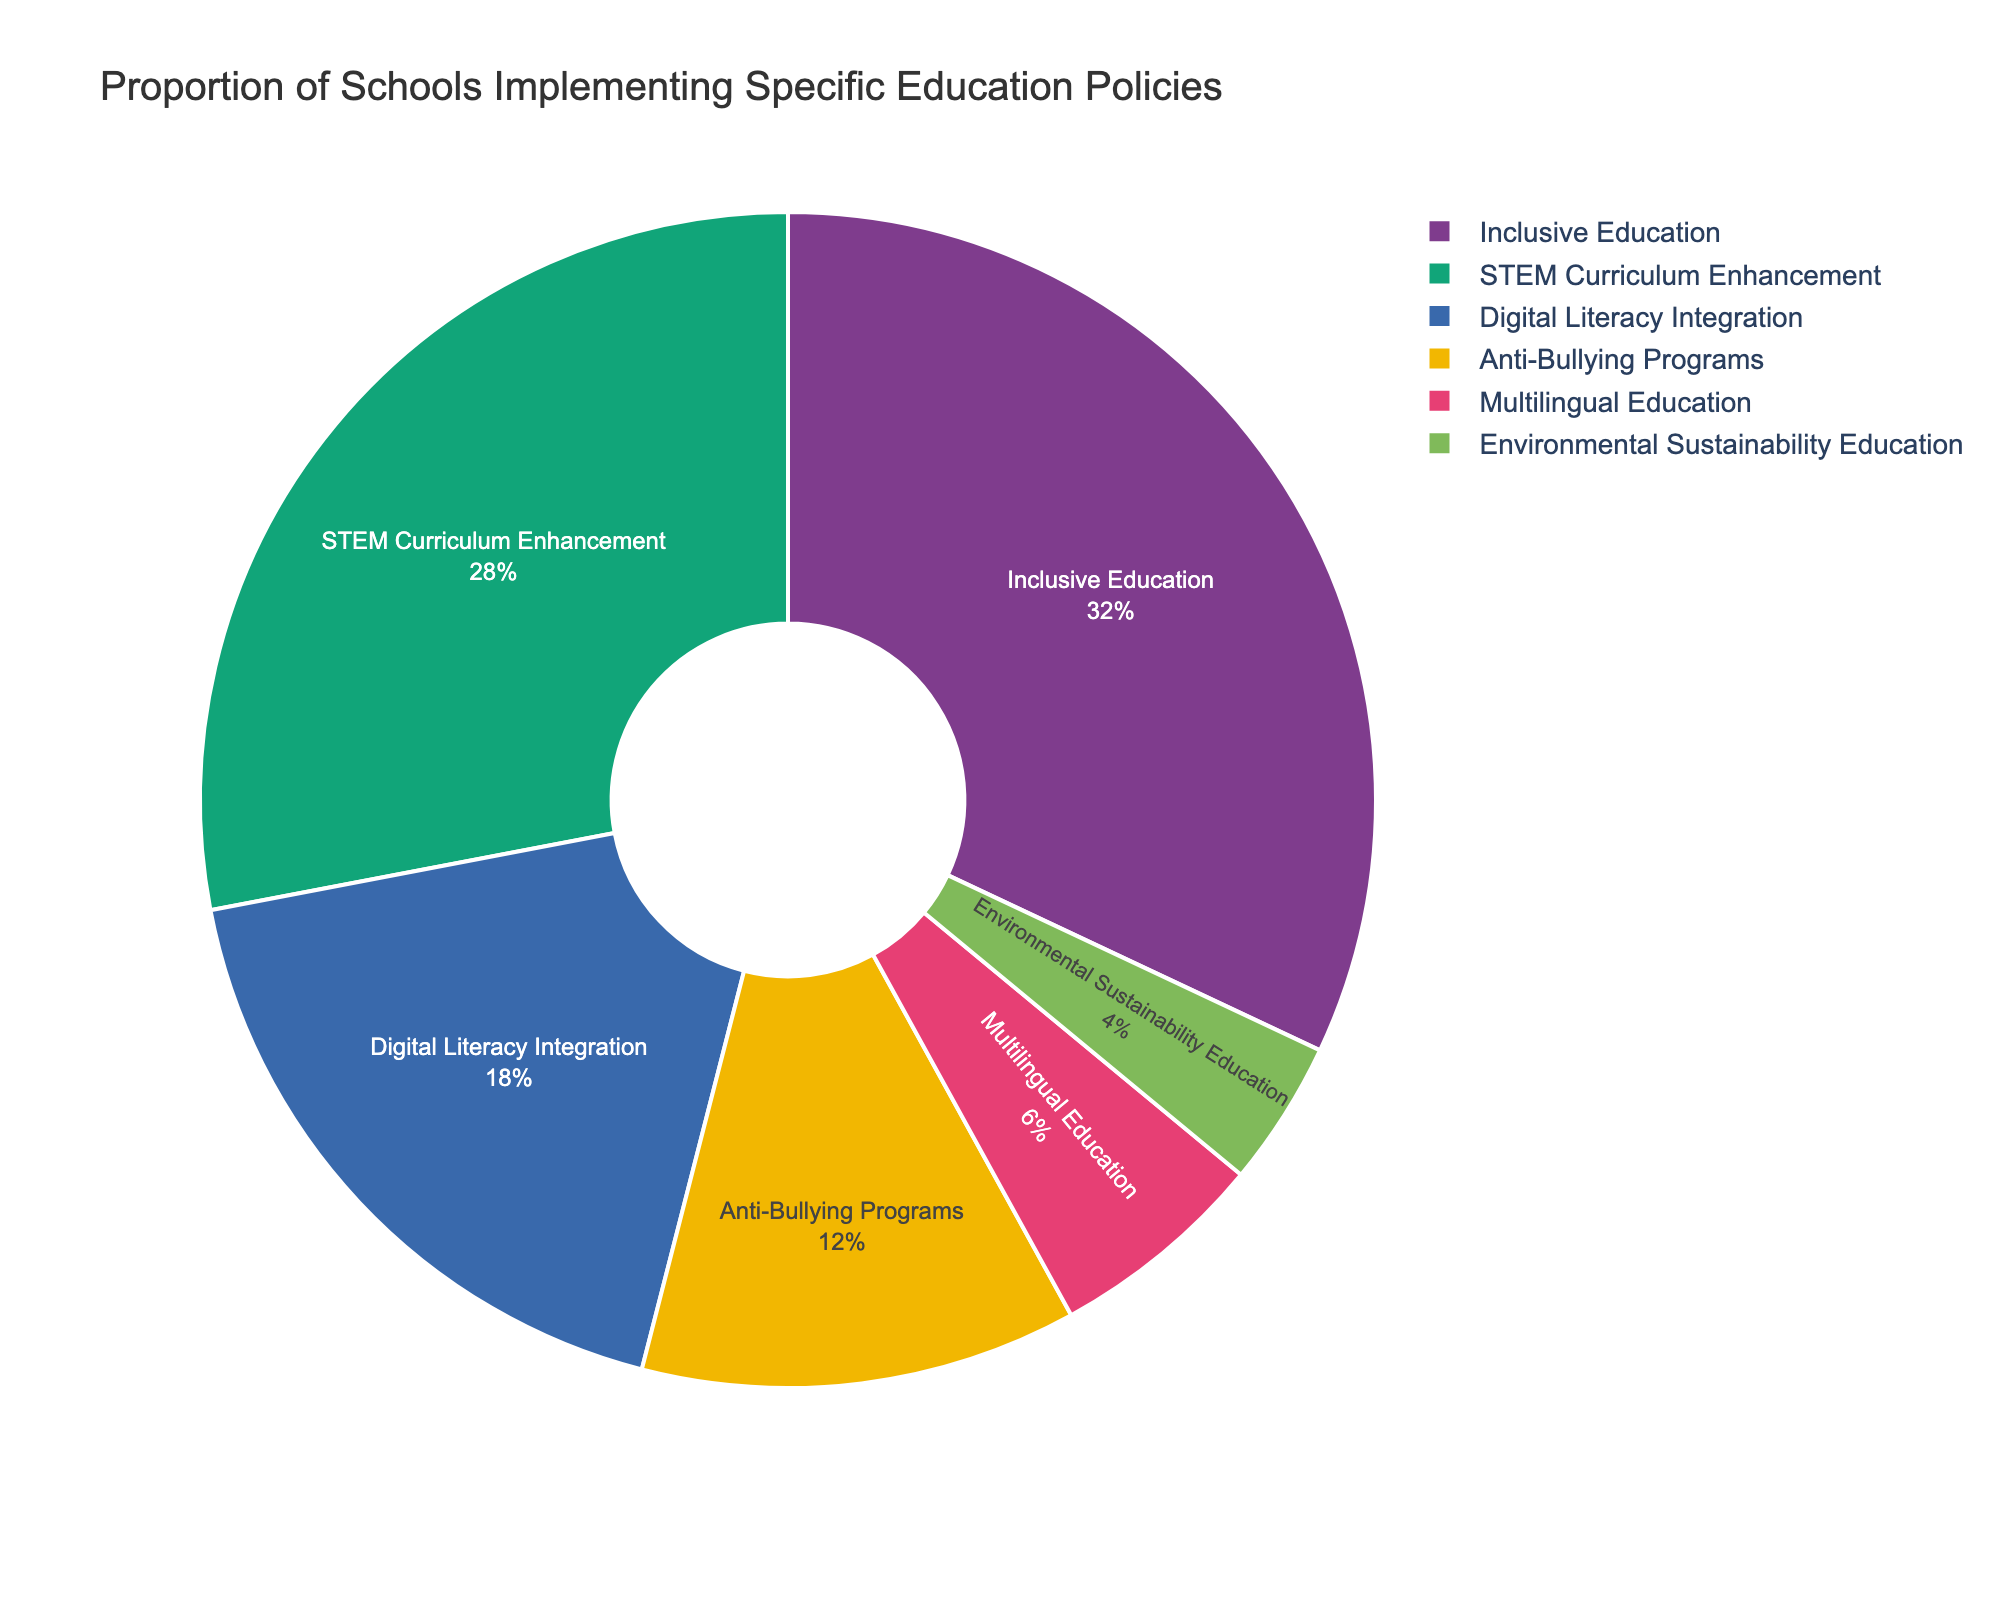What fraction of schools have implemented Inclusive Education and Digital Literacy Integration combined? The percentage of schools implementing Inclusive Education is 32% and for Digital Literacy Integration is 18%. Their combined fraction is (32 + 18)/100 = 50/100 = 0.5.
Answer: 0.5 Which policy is least implemented by schools? From the pie chart, Environmental Sustainability Education has the smallest segment, indicating it is the least implemented policy at 4%.
Answer: Environmental Sustainability Education How does the proportion of schools implementing STEM Curriculum Enhancement compare to those implementing Anti-Bullying Programs? The percentage for STEM Curriculum Enhancement is 28% and for Anti-Bullying Programs is 12%. 28% is more than double 12%.
Answer: STEM Curriculum Enhancement is more than double What is the difference in the proportion of schools implementing Inclusive Education and STEM Curriculum Enhancement? The percentage implementing Inclusive Education is 32% and for STEM Curriculum Enhancement is 28%. The difference is 32% - 28% = 4%.
Answer: 4% Which policy is represented by the second largest segment, and what percentage does it cover? The second largest segment in the pie chart corresponds to STEM Curriculum Enhancement, which covers 28% of schools.
Answer: STEM Curriculum Enhancement, 28% How many times larger is the proportion of schools implementing Inclusive Education compared to those implementing Multilingual Education? Inclusive Education is implemented by 32% of schools and Multilingual Education by 6%. The ratio is 32/6 = 5.33.
Answer: 5.33 times If you combine the schools implementing Anti-Bullying Programs and Multilingual Education, what percentage of schools does that represent? The percentage of schools implementing Anti-Bullying Programs is 12% and for Multilingual Education is 6%. Combined, that is 12% + 6% = 18%.
Answer: 18% Visually, which segment has the boldest color and what policy does it represent? The pie chart uses a color palette where bold colors are likely used. By observation, the segment representing Inclusive Education with the largest area (32%) has a bold color.
Answer: Inclusive Education If a policy is randomly selected from the chart, which policy has the highest probability of being selected? The policy with the highest proportion will have the highest probability. Inclusive Education, being the largest segment at 32%, has the highest probability.
Answer: Inclusive Education What is the combined proportion of schools implementing policies other than Inclusive Education? To find the combined proportion, subtract the percentage of Inclusive Education from 100%. That is 100% - 32% = 68%.
Answer: 68% 